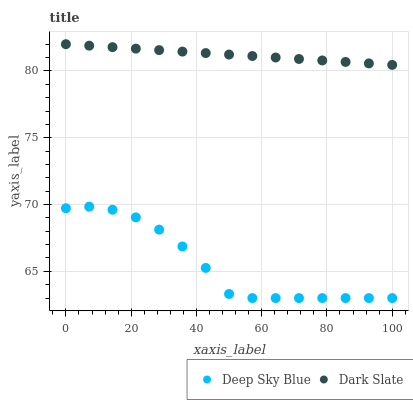Does Deep Sky Blue have the minimum area under the curve?
Answer yes or no. Yes. Does Dark Slate have the maximum area under the curve?
Answer yes or no. Yes. Does Deep Sky Blue have the maximum area under the curve?
Answer yes or no. No. Is Dark Slate the smoothest?
Answer yes or no. Yes. Is Deep Sky Blue the roughest?
Answer yes or no. Yes. Is Deep Sky Blue the smoothest?
Answer yes or no. No. Does Deep Sky Blue have the lowest value?
Answer yes or no. Yes. Does Dark Slate have the highest value?
Answer yes or no. Yes. Does Deep Sky Blue have the highest value?
Answer yes or no. No. Is Deep Sky Blue less than Dark Slate?
Answer yes or no. Yes. Is Dark Slate greater than Deep Sky Blue?
Answer yes or no. Yes. Does Deep Sky Blue intersect Dark Slate?
Answer yes or no. No. 